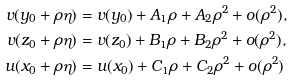<formula> <loc_0><loc_0><loc_500><loc_500>v ( y _ { 0 } + \rho \eta ) & = v ( y _ { 0 } ) + A _ { 1 } \rho + A _ { 2 } \rho ^ { 2 } + o ( \rho ^ { 2 } ) , \\ v ( z _ { 0 } + \rho \eta ) & = v ( z _ { 0 } ) + B _ { 1 } \rho + B _ { 2 } \rho ^ { 2 } + o ( \rho ^ { 2 } ) , \\ u ( x _ { 0 } + \rho \eta ) & = u ( x _ { 0 } ) + C _ { 1 } \rho + C _ { 2 } \rho ^ { 2 } + o ( \rho ^ { 2 } )</formula> 